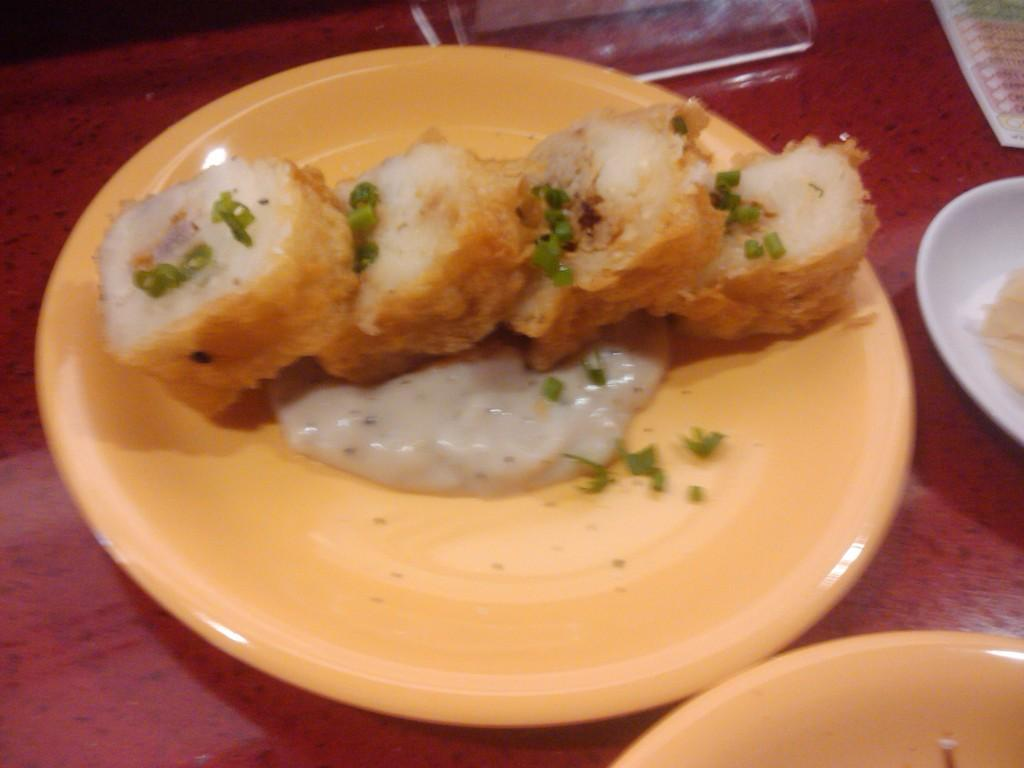What is on the table in the image? There is a plate with food on a table. Are there any other plates on the table? Yes, there are other plates on the table. What else can be seen on the table besides the plates? There are other things on the table. What type of popcorn is being served by the judge in the image? There is no popcorn or judge present in the image. 